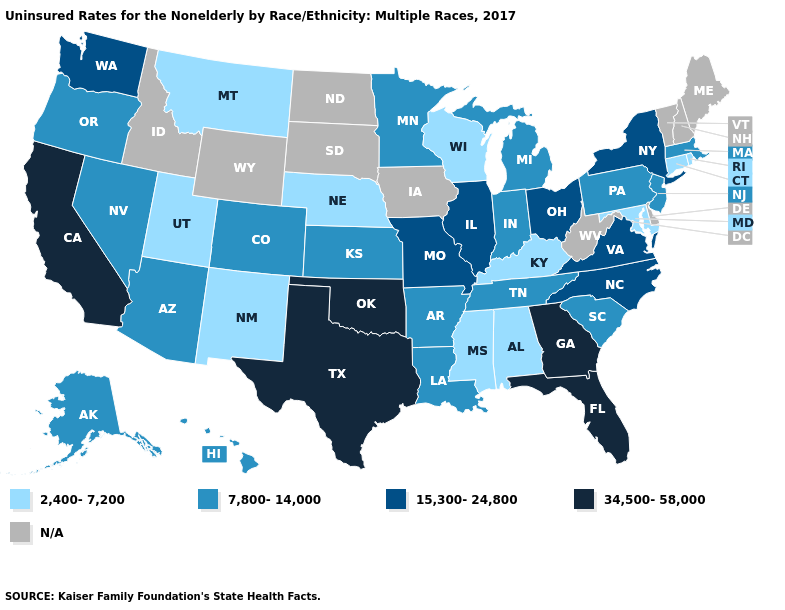What is the highest value in states that border West Virginia?
Short answer required. 15,300-24,800. Name the states that have a value in the range 7,800-14,000?
Be succinct. Alaska, Arizona, Arkansas, Colorado, Hawaii, Indiana, Kansas, Louisiana, Massachusetts, Michigan, Minnesota, Nevada, New Jersey, Oregon, Pennsylvania, South Carolina, Tennessee. Name the states that have a value in the range 7,800-14,000?
Answer briefly. Alaska, Arizona, Arkansas, Colorado, Hawaii, Indiana, Kansas, Louisiana, Massachusetts, Michigan, Minnesota, Nevada, New Jersey, Oregon, Pennsylvania, South Carolina, Tennessee. Among the states that border New Jersey , which have the lowest value?
Write a very short answer. Pennsylvania. What is the highest value in the South ?
Answer briefly. 34,500-58,000. Does New York have the lowest value in the Northeast?
Quick response, please. No. Which states have the lowest value in the USA?
Be succinct. Alabama, Connecticut, Kentucky, Maryland, Mississippi, Montana, Nebraska, New Mexico, Rhode Island, Utah, Wisconsin. What is the value of South Carolina?
Give a very brief answer. 7,800-14,000. Which states hav the highest value in the West?
Write a very short answer. California. Name the states that have a value in the range 34,500-58,000?
Give a very brief answer. California, Florida, Georgia, Oklahoma, Texas. What is the highest value in states that border North Dakota?
Give a very brief answer. 7,800-14,000. Does Texas have the highest value in the USA?
Give a very brief answer. Yes. What is the value of Missouri?
Write a very short answer. 15,300-24,800. 